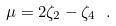Convert formula to latex. <formula><loc_0><loc_0><loc_500><loc_500>\mu = 2 \zeta _ { 2 } - \zeta _ { 4 } \ .</formula> 